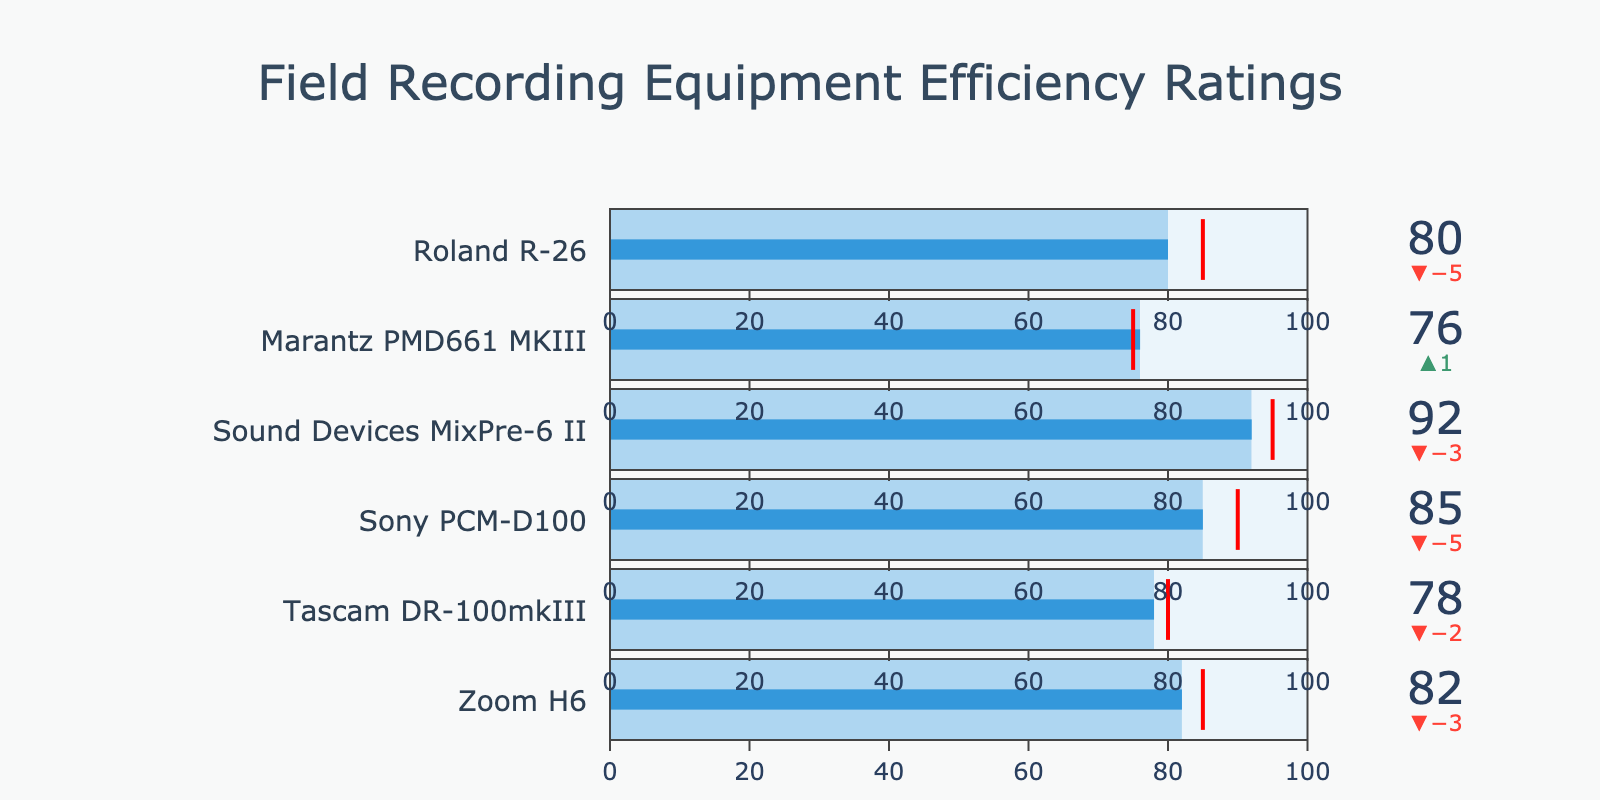How many pieces of equipment are evaluated in the figure? Count the number of bullet charts in the figure. There are 6 pieces of equipment listed: Zoom H6, Tascam DR-100mkIII, Sony PCM-D100, Sound Devices MixPre-6 II, Marantz PMD661 MKIII, and Roland R-26.
Answer: 6 Which equipment has the highest efficiency rating? By observing the value displayed on each bullet chart, the Sound Devices MixPre-6 II has the highest actual rating of 92.
Answer: Sound Devices MixPre-6 II What is the average target efficiency rating of the equipment? The target ratings are 85, 80, 90, 95, 75, and 85. Summing them gives 510. Dividing by the number of equipment (6), the average target rating is 510/6 = 85.
Answer: 85 Which equipment exceeded its target efficiency rating? Look for bullet charts where the actual rating is greater than the target rating. The Marantz PMD661 MKIII exceeded its target (76 > 75).
Answer: Marantz PMD661 MKIII What is the combined actual efficiency rating of the Zoom H6 and Sony PCM-D100? The actual ratings for Zoom H6 and Sony PCM-D100 are 82 and 85 respectively. Summing them gives 82 + 85 = 167.
Answer: 167 How much higher is the Sound Devices MixPre-6 II's actual rating compared to the Tascam DR-100mkIII’s target rating? Subtract Tascam DR-100mkIII’s target (80) from Sound Devices MixPre-6 II’s actual rating (92). The difference is 92 - 80 = 12.
Answer: 12 Which equipment has the smallest difference between its actual and target rating? Calculate the difference for each equipment and find the smallest: Zoom H6 (3), Tascam DR-100mkIII (2), Sony PCM-D100 (5), Sound Devices MixPre-6 II (3), Marantz PMD661 MKIII (-1, since it exceeded by 1), Roland R-26 (5). The smallest positive difference is for Tascam DR-100mkIII (2).
Answer: Tascam DR-100mkIII Which piece of equipment falls the furthest short of its target rating? Calculate the shortfall for each piece of equipment: Zoom H6 (3 short), Tascam DR-100mkIII (2 short), Sony PCM-D100 (5 short), Sound Devices MixPre-6 II (3 short), Roland R-26 (5 short). The furthest is Sony PCM-D100 and Roland R-26, both falling 5 units short.
Answer: Sony PCM-D100, Roland R-26 